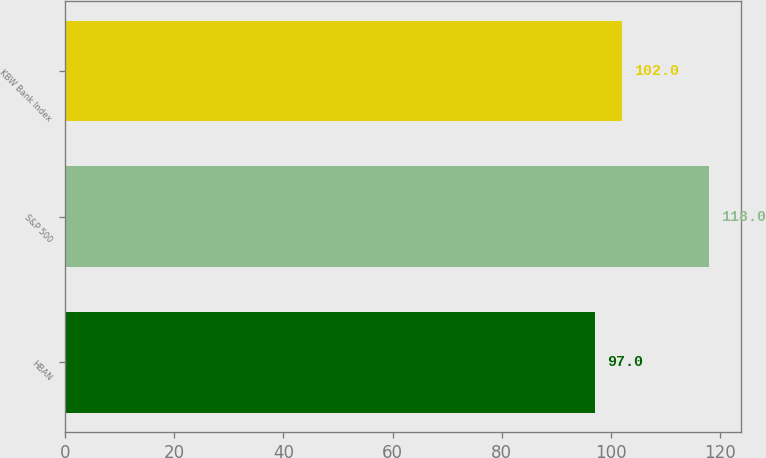Convert chart. <chart><loc_0><loc_0><loc_500><loc_500><bar_chart><fcel>HBAN<fcel>S&P 500<fcel>KBW Bank Index<nl><fcel>97<fcel>118<fcel>102<nl></chart> 